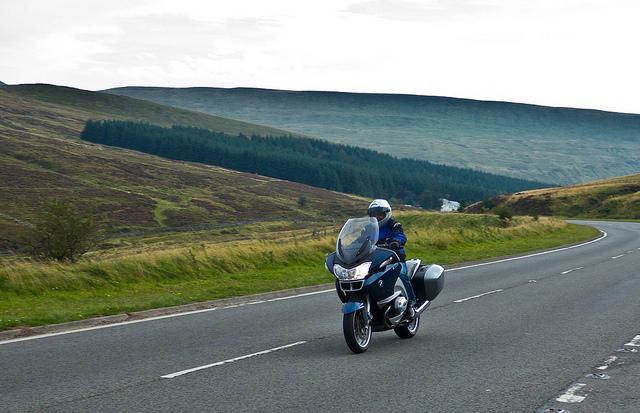Is this man in danger by being in the middle of the road?
Keep it brief. No. Are there a lot of bikers?
Write a very short answer. No. Can you see the ocean?
Be succinct. No. How many lanes are on this road?
Concise answer only. 2. Is there someone on the motorcycle?
Keep it brief. Yes. What number is displayed on the motorcycle?
Give a very brief answer. No number. What color is the bike?
Concise answer only. Blue. What is being ridden?
Write a very short answer. Motorcycle. How many people are on the motorcycle?
Keep it brief. 1. Is it daytime?
Be succinct. Yes. How many motorcycles are there?
Concise answer only. 1. Do all of the motorcycles have the headlights on?
Short answer required. No. 